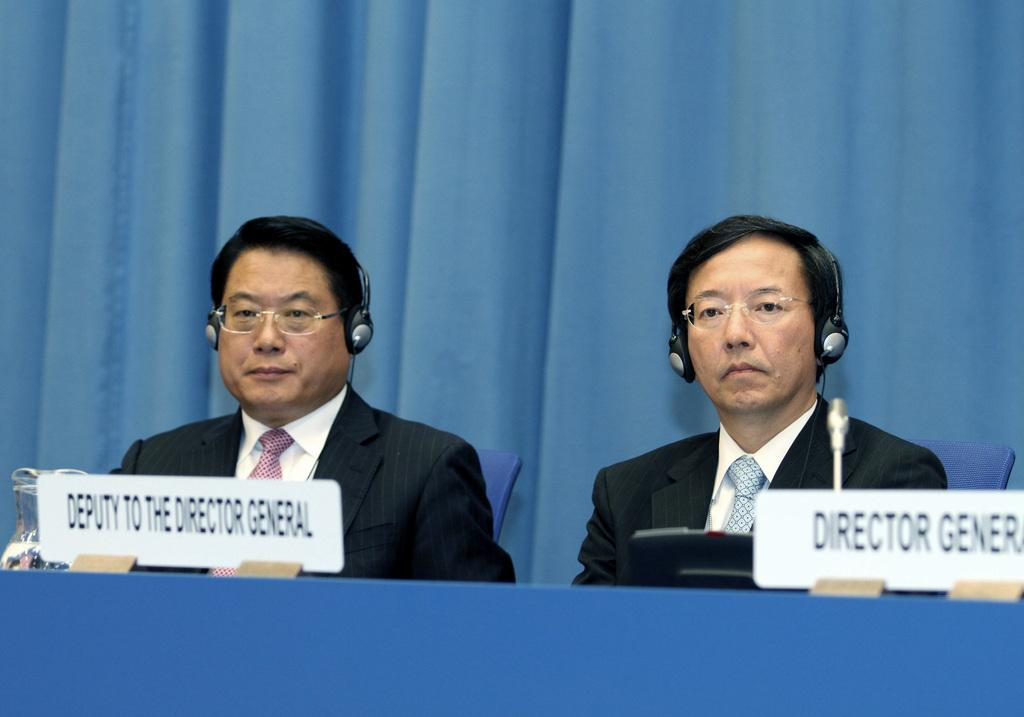<image>
Share a concise interpretation of the image provided. The director general and his deputy are sitting next to each other at a table. 